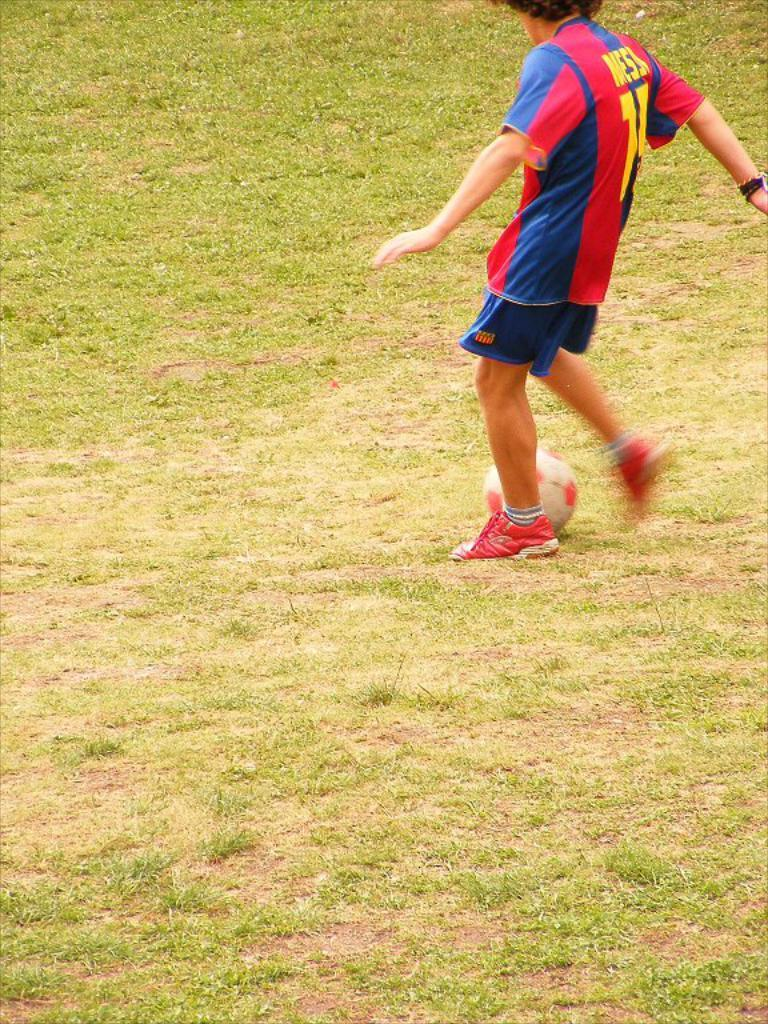<image>
Give a short and clear explanation of the subsequent image. Man wearing a number 71 jersey kicking a soccer ball on a grassy field. 